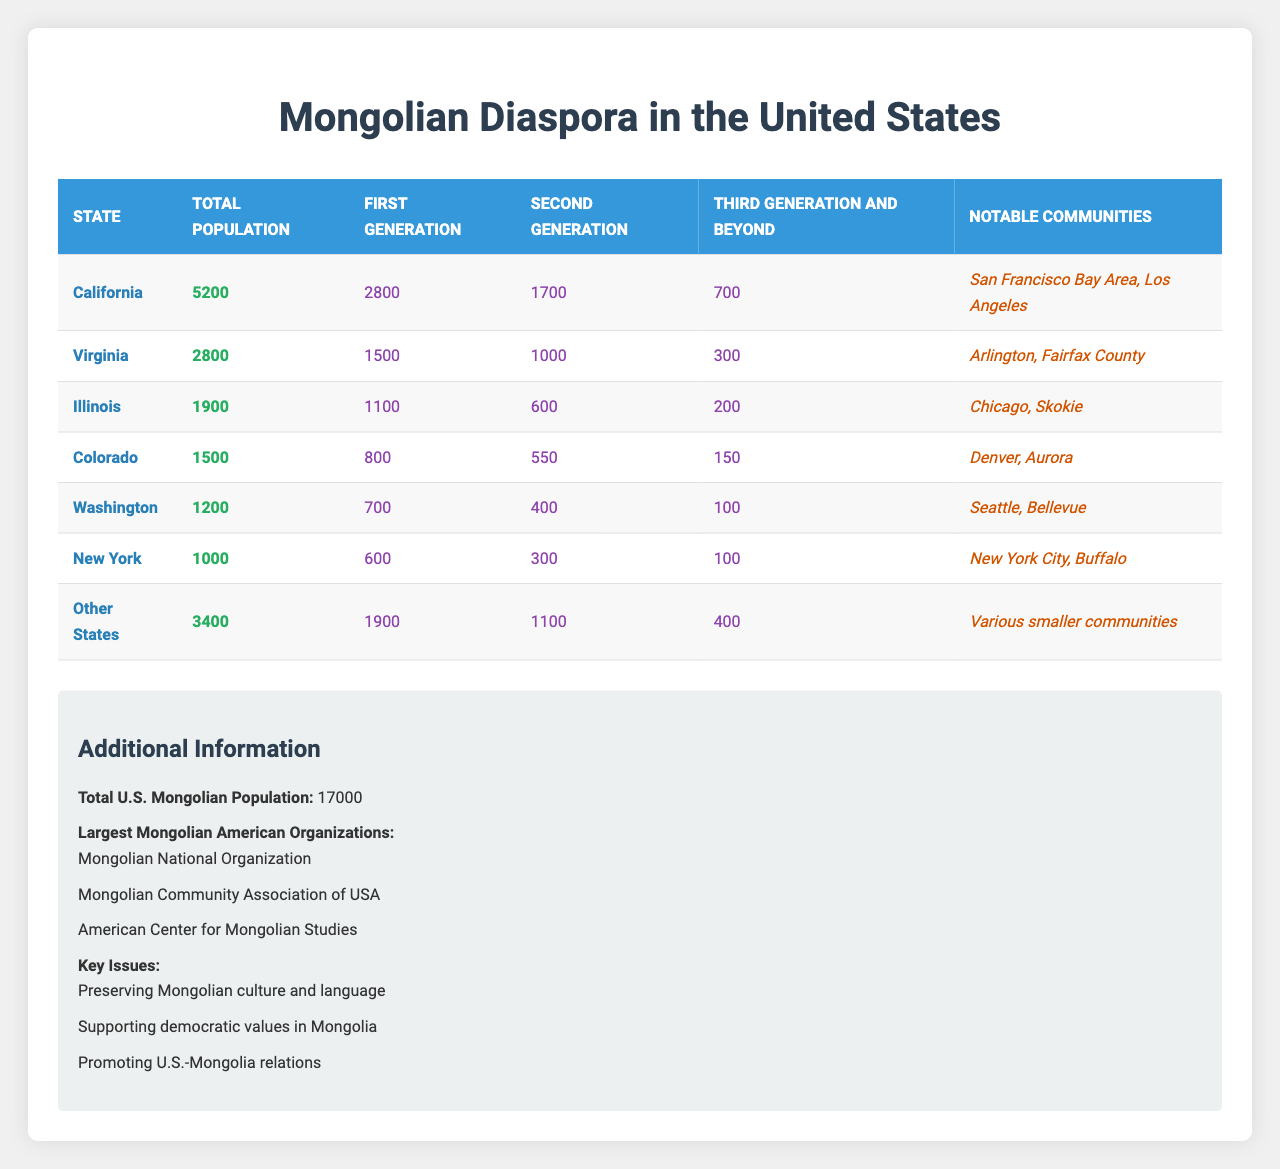What is the total population of the Mongolian diaspora in California? According to the table, the total population in California is listed as 5200.
Answer: 5200 How many first-generation Mongolians are there in Virginia? The table specifies that the first generation population in Virginia is 1500.
Answer: 1500 What is the combined total population of Mongolian diaspora in Illinois and Colorado? The populations in Illinois and Colorado are 1900 and 1500, respectively. Adding these gives 1900 + 1500 = 3400.
Answer: 3400 Is New York one of the states with notable Mongolian communities? The table indicates that New York has notable communities such as New York City and Buffalo, confirming that it is a state with Mongolian communities.
Answer: Yes What is the average number of third generation and beyond Mongolians across all listed states? The third generation numbers are 700 (California), 300 (Virginia), 200 (Illinois), 150 (Colorado), 100 (Washington), 100 (New York), and 400 (Other States). Summing these gives 700 + 300 + 200 + 150 + 100 + 100 + 400 = 1950. There are 7 entries, so the average is 1950/7 ≈ 278.57.
Answer: Approximately 278.57 Which state has the smallest population of the Mongolian diaspora? In comparing the populations listed, New York has the smallest total population of 1000.
Answer: 1000 What percentage of the total Mongolian diaspora population in the U.S. is in California? The total U.S. Mongolian population is 17000. California’s population is 5200. The calculation is (5200/17000) * 100 ≈ 30.59%.
Answer: Approximately 30.59% How many second-generation Mongolians are there in the "Other States"? The table indicates that the second generation population in "Other States" is 1100.
Answer: 1100 Which state has the highest number of first-generation Mongolians? Looking at the first generation populations, California has 2800, which is the highest among the listed states.
Answer: California What is the total number of Mongolian diaspora individuals from the third generation and beyond in Washington? The table shows that there are 100 individuals from the third generation and beyond in Washington.
Answer: 100 